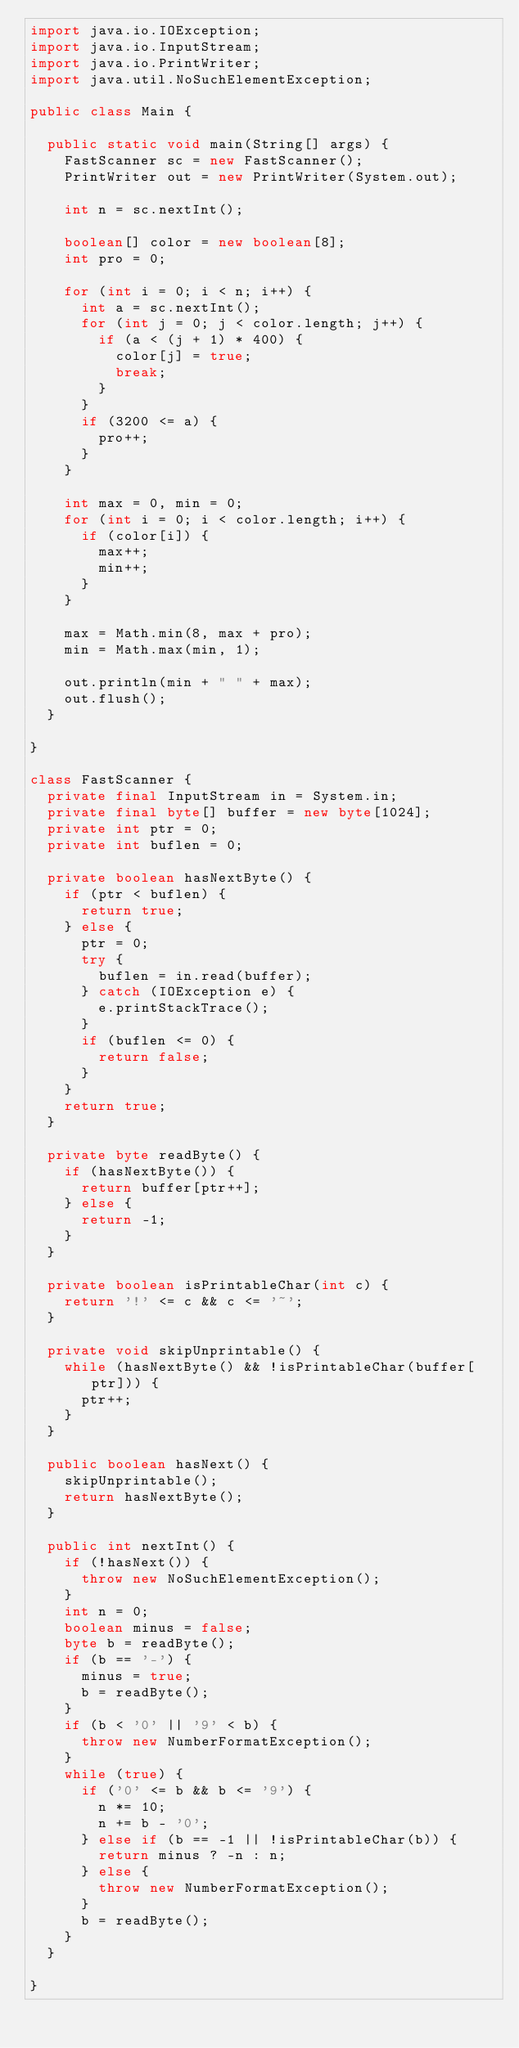<code> <loc_0><loc_0><loc_500><loc_500><_Java_>import java.io.IOException;
import java.io.InputStream;
import java.io.PrintWriter;
import java.util.NoSuchElementException;

public class Main {

	public static void main(String[] args) {
		FastScanner sc = new FastScanner();
		PrintWriter out = new PrintWriter(System.out);

		int n = sc.nextInt();

		boolean[] color = new boolean[8];
		int pro = 0;

		for (int i = 0; i < n; i++) {
			int a = sc.nextInt();
			for (int j = 0; j < color.length; j++) {
				if (a < (j + 1) * 400) {
					color[j] = true;
					break;
				}
			}
			if (3200 <= a) {
				pro++;
			}
		}

		int max = 0, min = 0;
		for (int i = 0; i < color.length; i++) {
			if (color[i]) {
				max++;
				min++;
			}
		}

		max = Math.min(8, max + pro);
		min = Math.max(min, 1);

		out.println(min + " " + max);
		out.flush();
	}

}

class FastScanner {
	private final InputStream in = System.in;
	private final byte[] buffer = new byte[1024];
	private int ptr = 0;
	private int buflen = 0;

	private boolean hasNextByte() {
		if (ptr < buflen) {
			return true;
		} else {
			ptr = 0;
			try {
				buflen = in.read(buffer);
			} catch (IOException e) {
				e.printStackTrace();
			}
			if (buflen <= 0) {
				return false;
			}
		}
		return true;
	}

	private byte readByte() {
		if (hasNextByte()) {
			return buffer[ptr++];
		} else {
			return -1;
		}
	}

	private boolean isPrintableChar(int c) {
		return '!' <= c && c <= '~';
	}

	private void skipUnprintable() {
		while (hasNextByte() && !isPrintableChar(buffer[ptr])) {
			ptr++;
		}
	}

	public boolean hasNext() {
		skipUnprintable();
		return hasNextByte();
	}

	public int nextInt() {
		if (!hasNext()) {
			throw new NoSuchElementException();
		}
		int n = 0;
		boolean minus = false;
		byte b = readByte();
		if (b == '-') {
			minus = true;
			b = readByte();
		}
		if (b < '0' || '9' < b) {
			throw new NumberFormatException();
		}
		while (true) {
			if ('0' <= b && b <= '9') {
				n *= 10;
				n += b - '0';
			} else if (b == -1 || !isPrintableChar(b)) {
				return minus ? -n : n;
			} else {
				throw new NumberFormatException();
			}
			b = readByte();
		}
	}

}</code> 